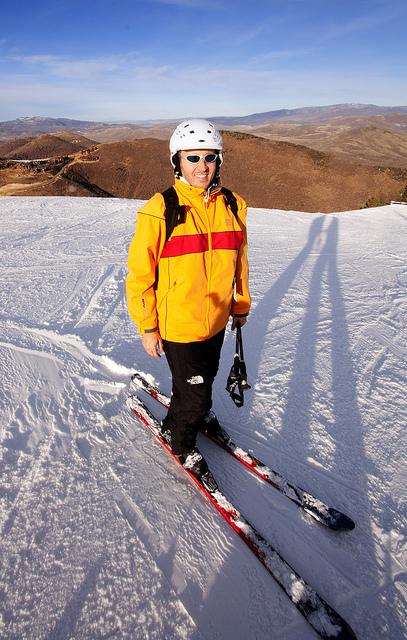Is this man casting a shadow?
Quick response, please. Yes. Are any of the people wearing goggles?
Short answer required. Yes. Is this person color coordinated?
Short answer required. Yes. What landforms are in the background?
Short answer required. Mountains. 